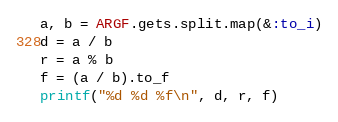Convert code to text. <code><loc_0><loc_0><loc_500><loc_500><_Ruby_>a, b = ARGF.gets.split.map(&:to_i)
d = a / b
r = a % b
f = (a / b).to_f
printf("%d %d %f\n", d, r, f)</code> 